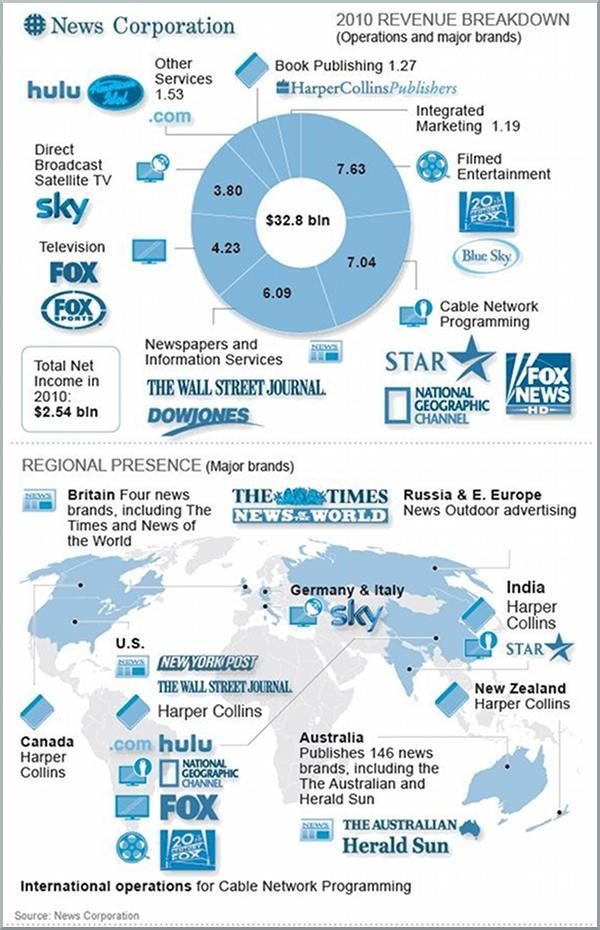Other than Canada, Harper Collins is present in which other countries
Answer the question with a short phrase. U.S, New Zealand, India Where was the highest revenue from in 2010 Filmed entertainment what was the total revenue in billions from Integrated marketing and book publishing 2.46 what major brand is present in Germany and Italy Sky Which brand is present in India star, harper collins 